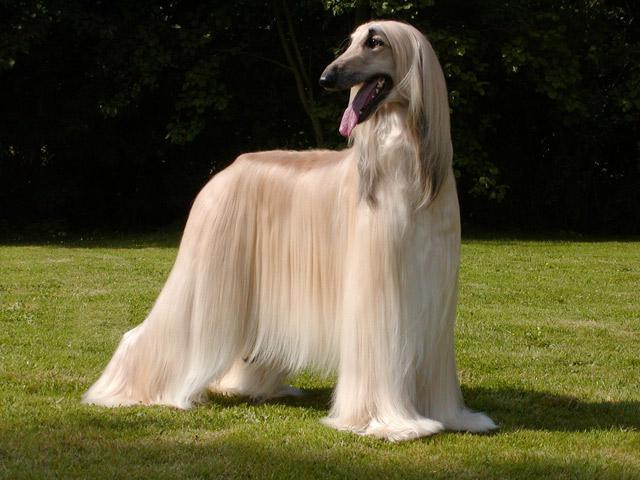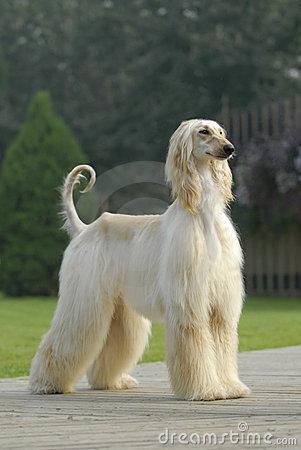The first image is the image on the left, the second image is the image on the right. Considering the images on both sides, is "The right image has a dog standing on a grassy surface" valid? Answer yes or no. No. The first image is the image on the left, the second image is the image on the right. For the images displayed, is the sentence "The dog in the left image is standing on snow-covered ground." factually correct? Answer yes or no. No. 